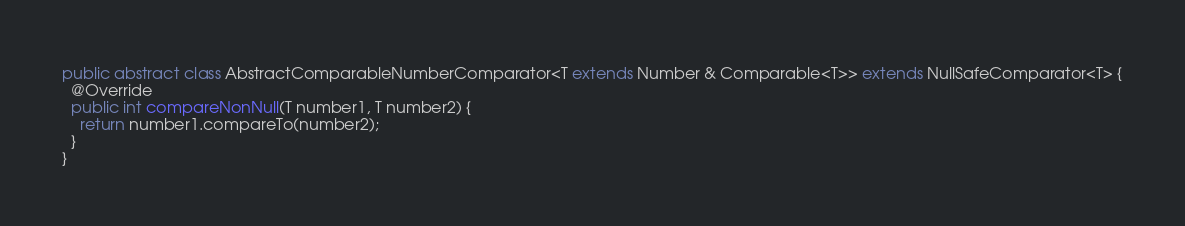<code> <loc_0><loc_0><loc_500><loc_500><_Java_>
public abstract class AbstractComparableNumberComparator<T extends Number & Comparable<T>> extends NullSafeComparator<T> {
  @Override
  public int compareNonNull(T number1, T number2) {
    return number1.compareTo(number2);
  }
}
</code> 